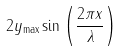Convert formula to latex. <formula><loc_0><loc_0><loc_500><loc_500>2 y _ { \max } \sin \left ( { \frac { 2 \pi x } { \lambda } } \right )</formula> 